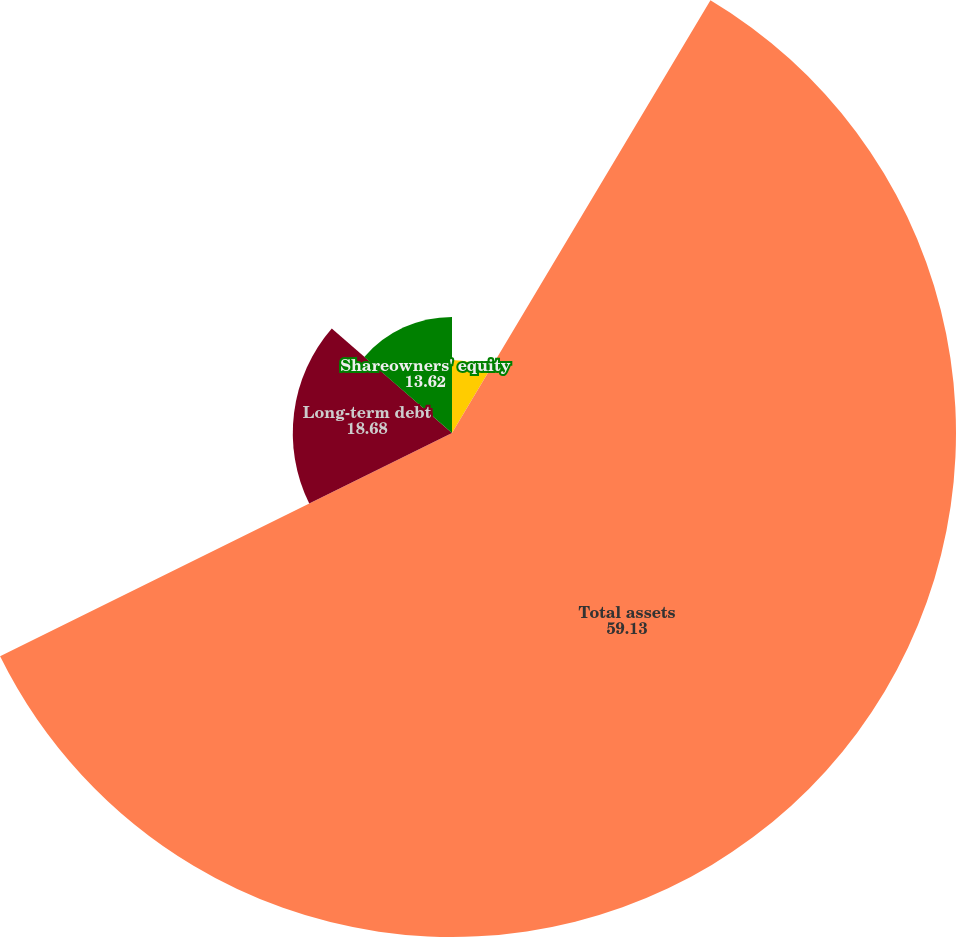Convert chart. <chart><loc_0><loc_0><loc_500><loc_500><pie_chart><fcel>Cash and marketable securities<fcel>Total assets<fcel>Long-term debt<fcel>Shareowners' equity<nl><fcel>8.57%<fcel>59.13%<fcel>18.68%<fcel>13.62%<nl></chart> 